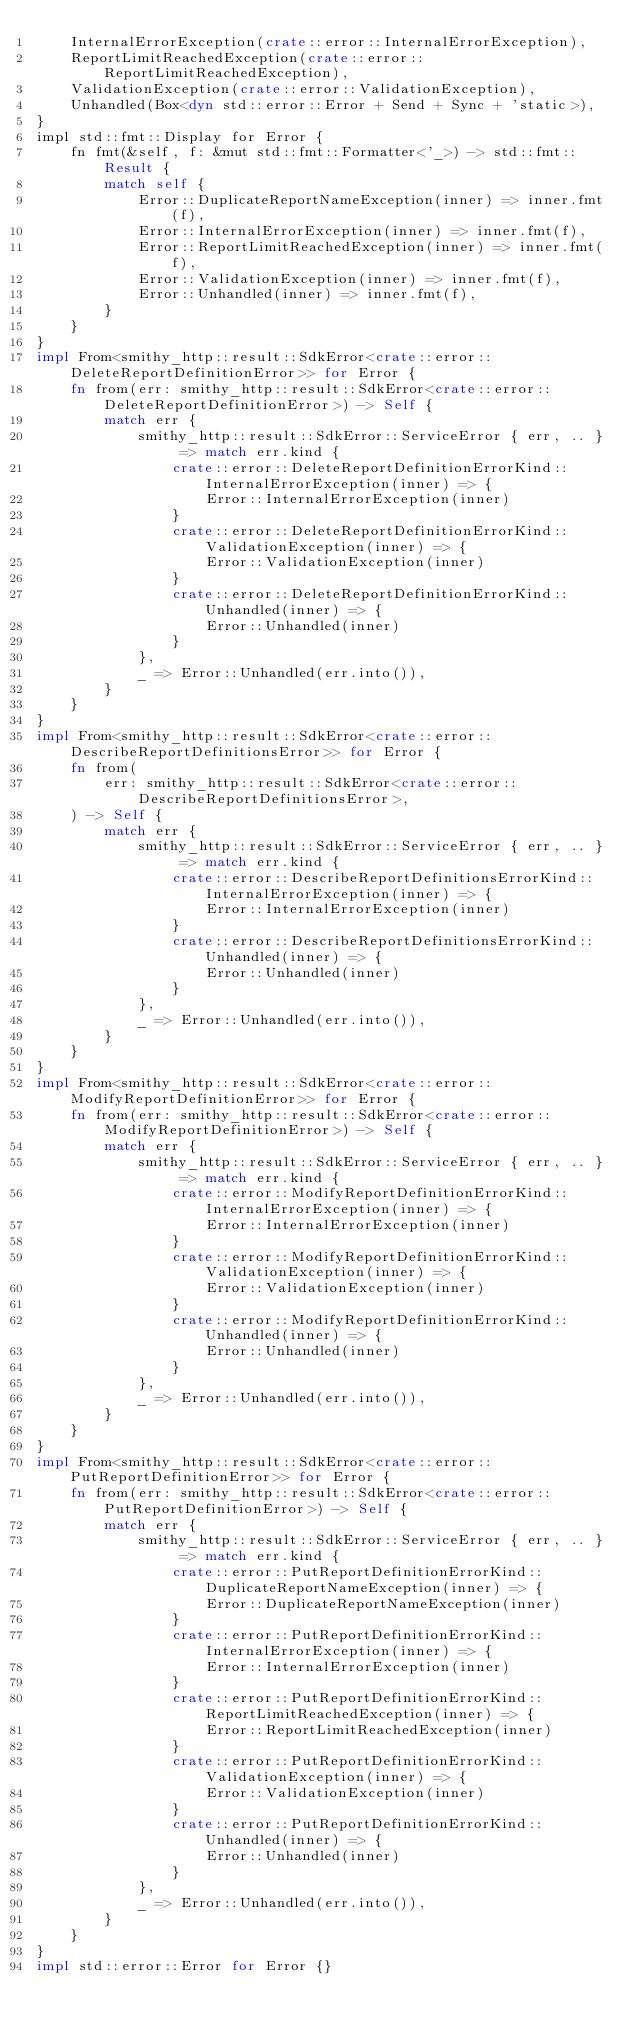Convert code to text. <code><loc_0><loc_0><loc_500><loc_500><_Rust_>    InternalErrorException(crate::error::InternalErrorException),
    ReportLimitReachedException(crate::error::ReportLimitReachedException),
    ValidationException(crate::error::ValidationException),
    Unhandled(Box<dyn std::error::Error + Send + Sync + 'static>),
}
impl std::fmt::Display for Error {
    fn fmt(&self, f: &mut std::fmt::Formatter<'_>) -> std::fmt::Result {
        match self {
            Error::DuplicateReportNameException(inner) => inner.fmt(f),
            Error::InternalErrorException(inner) => inner.fmt(f),
            Error::ReportLimitReachedException(inner) => inner.fmt(f),
            Error::ValidationException(inner) => inner.fmt(f),
            Error::Unhandled(inner) => inner.fmt(f),
        }
    }
}
impl From<smithy_http::result::SdkError<crate::error::DeleteReportDefinitionError>> for Error {
    fn from(err: smithy_http::result::SdkError<crate::error::DeleteReportDefinitionError>) -> Self {
        match err {
            smithy_http::result::SdkError::ServiceError { err, .. } => match err.kind {
                crate::error::DeleteReportDefinitionErrorKind::InternalErrorException(inner) => {
                    Error::InternalErrorException(inner)
                }
                crate::error::DeleteReportDefinitionErrorKind::ValidationException(inner) => {
                    Error::ValidationException(inner)
                }
                crate::error::DeleteReportDefinitionErrorKind::Unhandled(inner) => {
                    Error::Unhandled(inner)
                }
            },
            _ => Error::Unhandled(err.into()),
        }
    }
}
impl From<smithy_http::result::SdkError<crate::error::DescribeReportDefinitionsError>> for Error {
    fn from(
        err: smithy_http::result::SdkError<crate::error::DescribeReportDefinitionsError>,
    ) -> Self {
        match err {
            smithy_http::result::SdkError::ServiceError { err, .. } => match err.kind {
                crate::error::DescribeReportDefinitionsErrorKind::InternalErrorException(inner) => {
                    Error::InternalErrorException(inner)
                }
                crate::error::DescribeReportDefinitionsErrorKind::Unhandled(inner) => {
                    Error::Unhandled(inner)
                }
            },
            _ => Error::Unhandled(err.into()),
        }
    }
}
impl From<smithy_http::result::SdkError<crate::error::ModifyReportDefinitionError>> for Error {
    fn from(err: smithy_http::result::SdkError<crate::error::ModifyReportDefinitionError>) -> Self {
        match err {
            smithy_http::result::SdkError::ServiceError { err, .. } => match err.kind {
                crate::error::ModifyReportDefinitionErrorKind::InternalErrorException(inner) => {
                    Error::InternalErrorException(inner)
                }
                crate::error::ModifyReportDefinitionErrorKind::ValidationException(inner) => {
                    Error::ValidationException(inner)
                }
                crate::error::ModifyReportDefinitionErrorKind::Unhandled(inner) => {
                    Error::Unhandled(inner)
                }
            },
            _ => Error::Unhandled(err.into()),
        }
    }
}
impl From<smithy_http::result::SdkError<crate::error::PutReportDefinitionError>> for Error {
    fn from(err: smithy_http::result::SdkError<crate::error::PutReportDefinitionError>) -> Self {
        match err {
            smithy_http::result::SdkError::ServiceError { err, .. } => match err.kind {
                crate::error::PutReportDefinitionErrorKind::DuplicateReportNameException(inner) => {
                    Error::DuplicateReportNameException(inner)
                }
                crate::error::PutReportDefinitionErrorKind::InternalErrorException(inner) => {
                    Error::InternalErrorException(inner)
                }
                crate::error::PutReportDefinitionErrorKind::ReportLimitReachedException(inner) => {
                    Error::ReportLimitReachedException(inner)
                }
                crate::error::PutReportDefinitionErrorKind::ValidationException(inner) => {
                    Error::ValidationException(inner)
                }
                crate::error::PutReportDefinitionErrorKind::Unhandled(inner) => {
                    Error::Unhandled(inner)
                }
            },
            _ => Error::Unhandled(err.into()),
        }
    }
}
impl std::error::Error for Error {}
</code> 